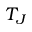Convert formula to latex. <formula><loc_0><loc_0><loc_500><loc_500>T _ { J }</formula> 